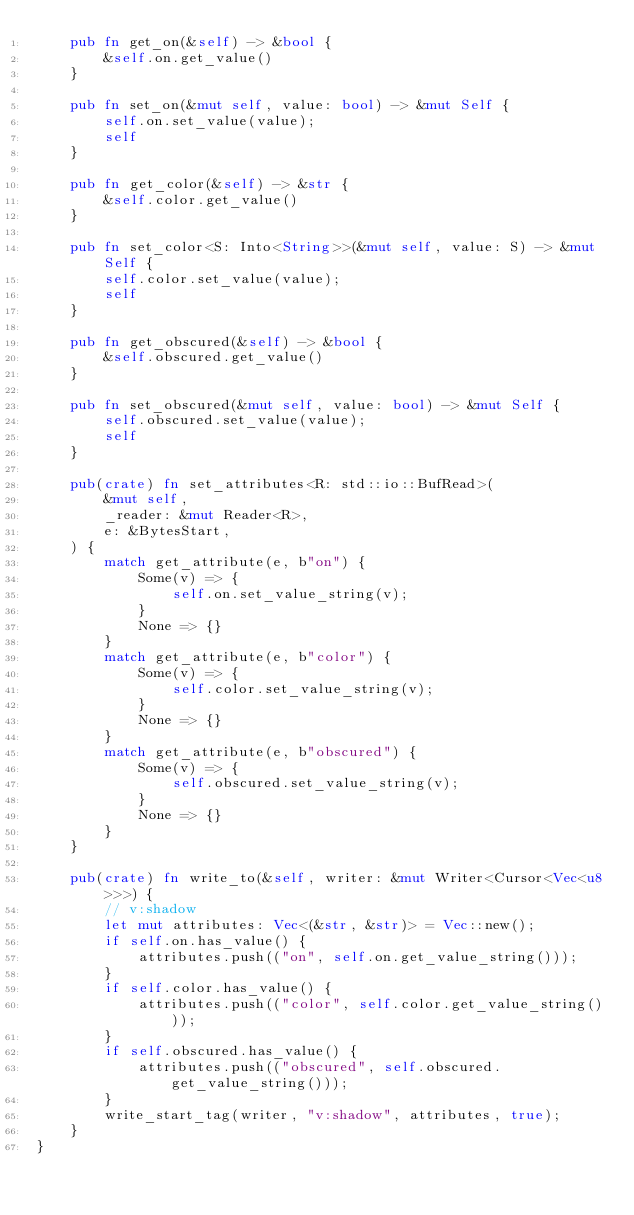<code> <loc_0><loc_0><loc_500><loc_500><_Rust_>    pub fn get_on(&self) -> &bool {
        &self.on.get_value()
    }

    pub fn set_on(&mut self, value: bool) -> &mut Self {
        self.on.set_value(value);
        self
    }

    pub fn get_color(&self) -> &str {
        &self.color.get_value()
    }

    pub fn set_color<S: Into<String>>(&mut self, value: S) -> &mut Self {
        self.color.set_value(value);
        self
    }

    pub fn get_obscured(&self) -> &bool {
        &self.obscured.get_value()
    }

    pub fn set_obscured(&mut self, value: bool) -> &mut Self {
        self.obscured.set_value(value);
        self
    }

    pub(crate) fn set_attributes<R: std::io::BufRead>(
        &mut self,
        _reader: &mut Reader<R>,
        e: &BytesStart,
    ) {
        match get_attribute(e, b"on") {
            Some(v) => {
                self.on.set_value_string(v);
            }
            None => {}
        }
        match get_attribute(e, b"color") {
            Some(v) => {
                self.color.set_value_string(v);
            }
            None => {}
        }
        match get_attribute(e, b"obscured") {
            Some(v) => {
                self.obscured.set_value_string(v);
            }
            None => {}
        }
    }

    pub(crate) fn write_to(&self, writer: &mut Writer<Cursor<Vec<u8>>>) {
        // v:shadow
        let mut attributes: Vec<(&str, &str)> = Vec::new();
        if self.on.has_value() {
            attributes.push(("on", self.on.get_value_string()));
        }
        if self.color.has_value() {
            attributes.push(("color", self.color.get_value_string()));
        }
        if self.obscured.has_value() {
            attributes.push(("obscured", self.obscured.get_value_string()));
        }
        write_start_tag(writer, "v:shadow", attributes, true);
    }
}
</code> 